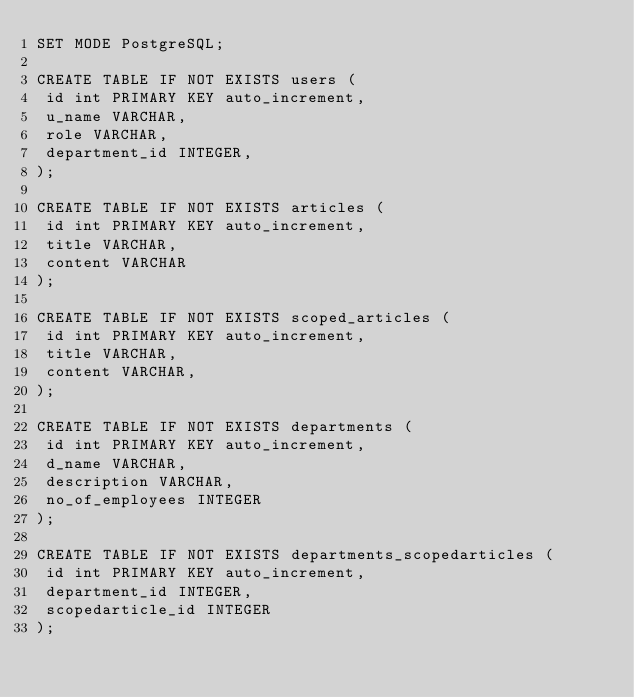Convert code to text. <code><loc_0><loc_0><loc_500><loc_500><_SQL_>SET MODE PostgreSQL;

CREATE TABLE IF NOT EXISTS users (
 id int PRIMARY KEY auto_increment,
 u_name VARCHAR,
 role VARCHAR,
 department_id INTEGER,
);

CREATE TABLE IF NOT EXISTS articles (
 id int PRIMARY KEY auto_increment,
 title VARCHAR,
 content VARCHAR
);

CREATE TABLE IF NOT EXISTS scoped_articles (
 id int PRIMARY KEY auto_increment,
 title VARCHAR,
 content VARCHAR,
);

CREATE TABLE IF NOT EXISTS departments (
 id int PRIMARY KEY auto_increment,
 d_name VARCHAR,
 description VARCHAR,
 no_of_employees INTEGER
);

CREATE TABLE IF NOT EXISTS departments_scopedarticles (
 id int PRIMARY KEY auto_increment,
 department_id INTEGER,
 scopedarticle_id INTEGER
);


</code> 